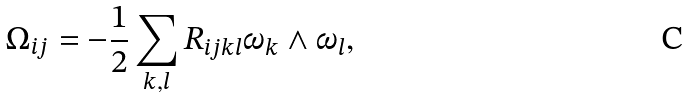<formula> <loc_0><loc_0><loc_500><loc_500>\Omega _ { i j } = - \frac { 1 } { 2 } \sum _ { k , l } R _ { i j k l } \omega _ { k } \wedge \omega _ { l } ,</formula> 